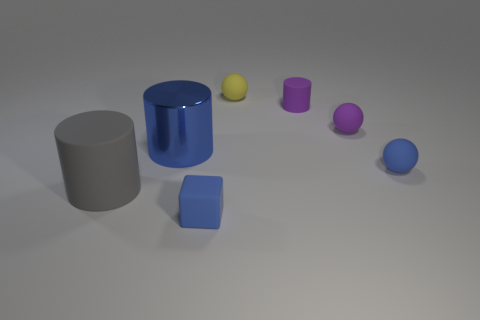How many objects in the image have a matte finish? Three objects in the image have a matte finish, which are the grey cylinder, the small purple object, and the cube. 